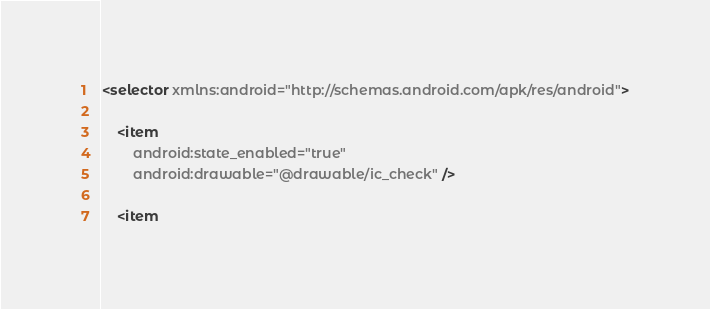Convert code to text. <code><loc_0><loc_0><loc_500><loc_500><_XML_><selector xmlns:android="http://schemas.android.com/apk/res/android">

    <item
        android:state_enabled="true"
        android:drawable="@drawable/ic_check" />

    <item</code> 